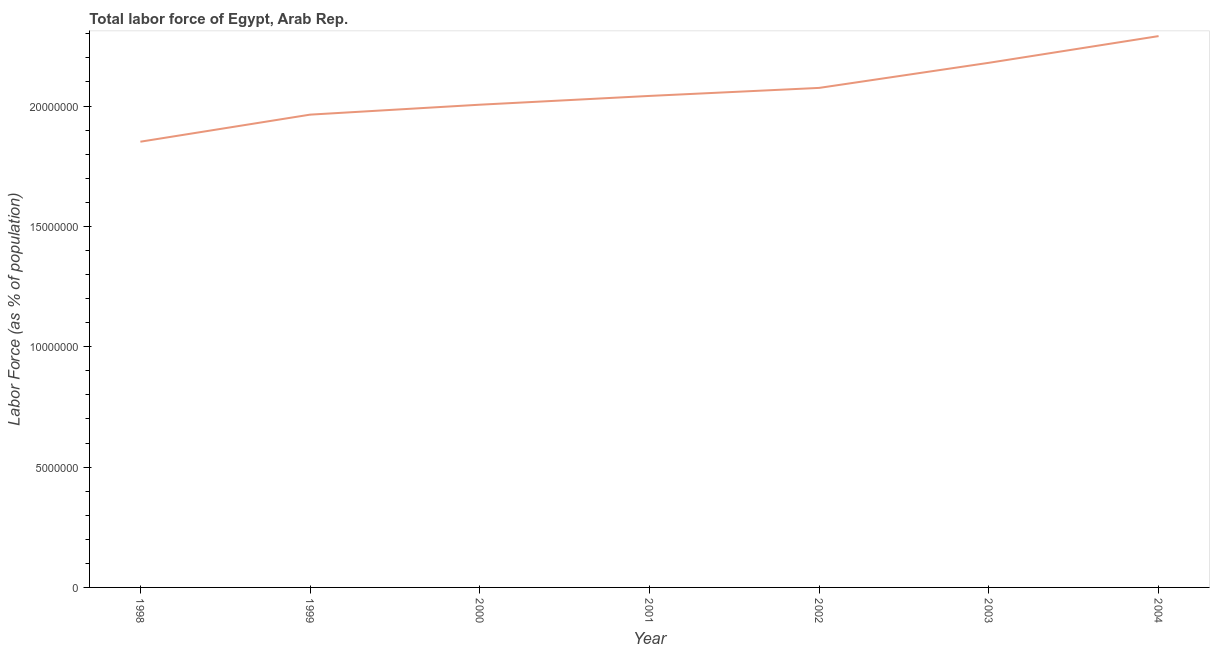What is the total labor force in 2001?
Provide a succinct answer. 2.04e+07. Across all years, what is the maximum total labor force?
Provide a succinct answer. 2.29e+07. Across all years, what is the minimum total labor force?
Your answer should be compact. 1.85e+07. In which year was the total labor force maximum?
Offer a very short reply. 2004. In which year was the total labor force minimum?
Ensure brevity in your answer.  1998. What is the sum of the total labor force?
Offer a terse response. 1.44e+08. What is the difference between the total labor force in 2000 and 2004?
Ensure brevity in your answer.  -2.85e+06. What is the average total labor force per year?
Make the answer very short. 2.06e+07. What is the median total labor force?
Offer a very short reply. 2.04e+07. Do a majority of the years between 2003 and 2002 (inclusive) have total labor force greater than 18000000 %?
Provide a short and direct response. No. What is the ratio of the total labor force in 1999 to that in 2001?
Your answer should be very brief. 0.96. What is the difference between the highest and the second highest total labor force?
Give a very brief answer. 1.11e+06. What is the difference between the highest and the lowest total labor force?
Your response must be concise. 4.39e+06. How many lines are there?
Offer a very short reply. 1. How many years are there in the graph?
Offer a terse response. 7. What is the difference between two consecutive major ticks on the Y-axis?
Give a very brief answer. 5.00e+06. Are the values on the major ticks of Y-axis written in scientific E-notation?
Your answer should be compact. No. What is the title of the graph?
Give a very brief answer. Total labor force of Egypt, Arab Rep. What is the label or title of the Y-axis?
Offer a terse response. Labor Force (as % of population). What is the Labor Force (as % of population) in 1998?
Your response must be concise. 1.85e+07. What is the Labor Force (as % of population) of 1999?
Your answer should be very brief. 1.96e+07. What is the Labor Force (as % of population) in 2000?
Provide a short and direct response. 2.01e+07. What is the Labor Force (as % of population) of 2001?
Your response must be concise. 2.04e+07. What is the Labor Force (as % of population) in 2002?
Your answer should be very brief. 2.08e+07. What is the Labor Force (as % of population) in 2003?
Give a very brief answer. 2.18e+07. What is the Labor Force (as % of population) of 2004?
Make the answer very short. 2.29e+07. What is the difference between the Labor Force (as % of population) in 1998 and 1999?
Ensure brevity in your answer.  -1.12e+06. What is the difference between the Labor Force (as % of population) in 1998 and 2000?
Provide a short and direct response. -1.54e+06. What is the difference between the Labor Force (as % of population) in 1998 and 2001?
Your answer should be very brief. -1.90e+06. What is the difference between the Labor Force (as % of population) in 1998 and 2002?
Offer a very short reply. -2.24e+06. What is the difference between the Labor Force (as % of population) in 1998 and 2003?
Give a very brief answer. -3.28e+06. What is the difference between the Labor Force (as % of population) in 1998 and 2004?
Ensure brevity in your answer.  -4.39e+06. What is the difference between the Labor Force (as % of population) in 1999 and 2000?
Provide a short and direct response. -4.13e+05. What is the difference between the Labor Force (as % of population) in 1999 and 2001?
Give a very brief answer. -7.78e+05. What is the difference between the Labor Force (as % of population) in 1999 and 2002?
Your response must be concise. -1.11e+06. What is the difference between the Labor Force (as % of population) in 1999 and 2003?
Your answer should be very brief. -2.15e+06. What is the difference between the Labor Force (as % of population) in 1999 and 2004?
Give a very brief answer. -3.26e+06. What is the difference between the Labor Force (as % of population) in 2000 and 2001?
Your answer should be compact. -3.65e+05. What is the difference between the Labor Force (as % of population) in 2000 and 2002?
Your answer should be very brief. -6.98e+05. What is the difference between the Labor Force (as % of population) in 2000 and 2003?
Provide a succinct answer. -1.74e+06. What is the difference between the Labor Force (as % of population) in 2000 and 2004?
Offer a terse response. -2.85e+06. What is the difference between the Labor Force (as % of population) in 2001 and 2002?
Offer a very short reply. -3.33e+05. What is the difference between the Labor Force (as % of population) in 2001 and 2003?
Offer a very short reply. -1.38e+06. What is the difference between the Labor Force (as % of population) in 2001 and 2004?
Make the answer very short. -2.49e+06. What is the difference between the Labor Force (as % of population) in 2002 and 2003?
Ensure brevity in your answer.  -1.04e+06. What is the difference between the Labor Force (as % of population) in 2002 and 2004?
Your answer should be very brief. -2.15e+06. What is the difference between the Labor Force (as % of population) in 2003 and 2004?
Your answer should be compact. -1.11e+06. What is the ratio of the Labor Force (as % of population) in 1998 to that in 1999?
Offer a very short reply. 0.94. What is the ratio of the Labor Force (as % of population) in 1998 to that in 2000?
Your answer should be compact. 0.92. What is the ratio of the Labor Force (as % of population) in 1998 to that in 2001?
Offer a very short reply. 0.91. What is the ratio of the Labor Force (as % of population) in 1998 to that in 2002?
Keep it short and to the point. 0.89. What is the ratio of the Labor Force (as % of population) in 1998 to that in 2004?
Give a very brief answer. 0.81. What is the ratio of the Labor Force (as % of population) in 1999 to that in 2002?
Your response must be concise. 0.95. What is the ratio of the Labor Force (as % of population) in 1999 to that in 2003?
Your answer should be very brief. 0.9. What is the ratio of the Labor Force (as % of population) in 1999 to that in 2004?
Ensure brevity in your answer.  0.86. What is the ratio of the Labor Force (as % of population) in 2000 to that in 2001?
Your answer should be very brief. 0.98. What is the ratio of the Labor Force (as % of population) in 2000 to that in 2003?
Offer a terse response. 0.92. What is the ratio of the Labor Force (as % of population) in 2000 to that in 2004?
Give a very brief answer. 0.88. What is the ratio of the Labor Force (as % of population) in 2001 to that in 2003?
Your answer should be very brief. 0.94. What is the ratio of the Labor Force (as % of population) in 2001 to that in 2004?
Your response must be concise. 0.89. What is the ratio of the Labor Force (as % of population) in 2002 to that in 2003?
Keep it short and to the point. 0.95. What is the ratio of the Labor Force (as % of population) in 2002 to that in 2004?
Offer a very short reply. 0.91. 